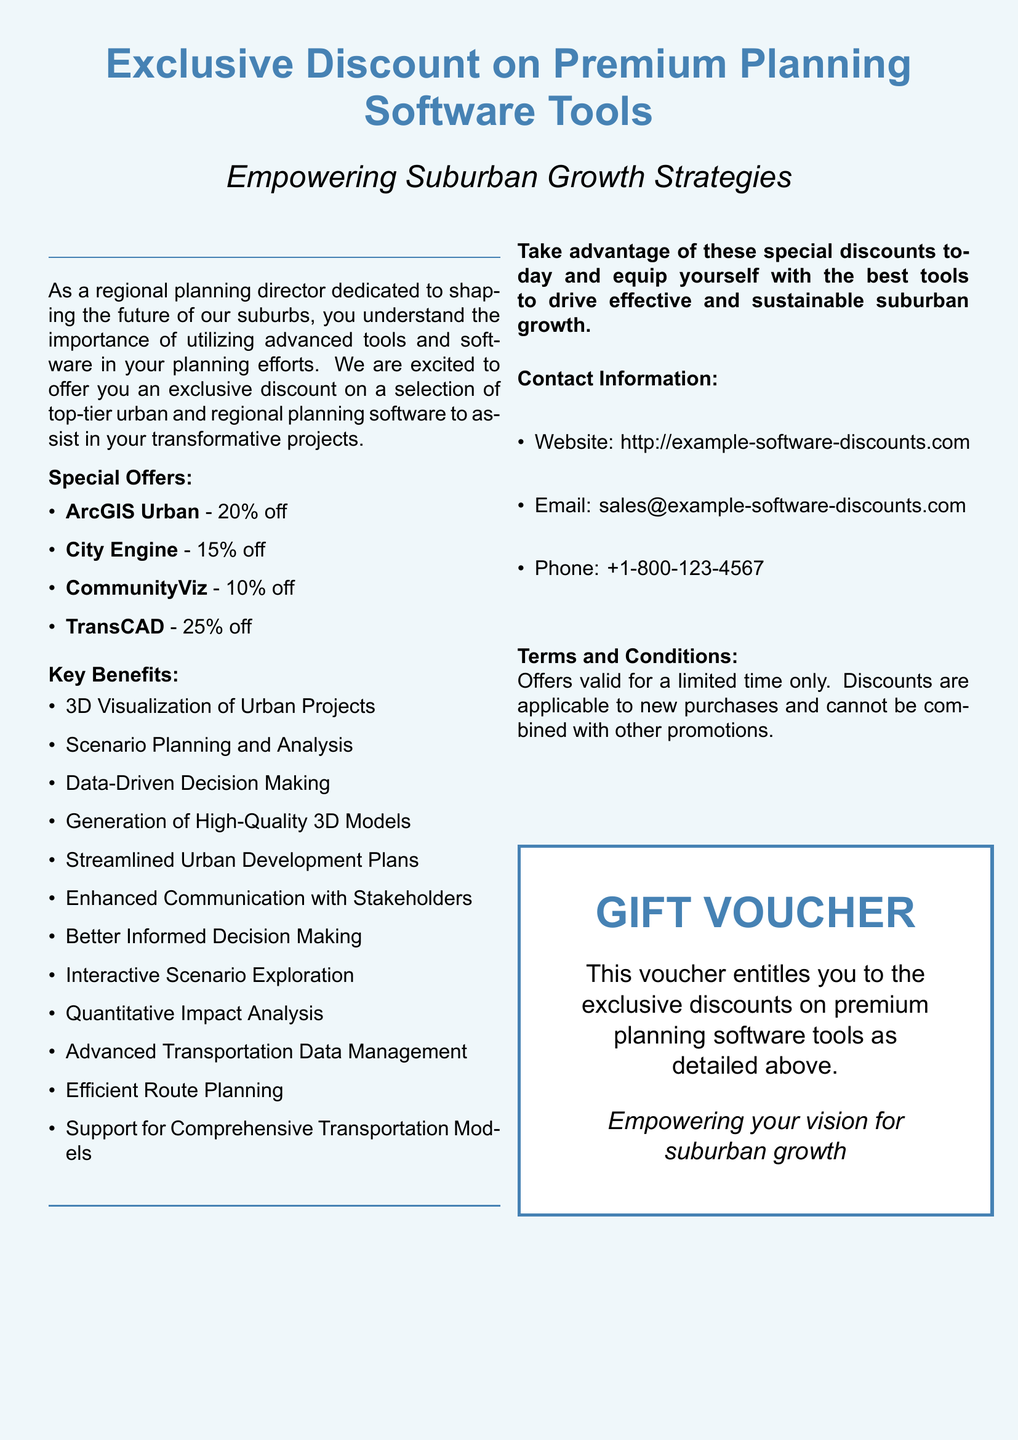What is the discount percentage for ArcGIS Urban? The discount for ArcGIS Urban is specifically mentioned in the document as 20%.
Answer: 20% What is the main purpose of the voucher? The main purpose of the voucher is detailed as empowering suburban growth strategies through the usage of advanced planning software tools.
Answer: Empowering suburban growth strategies How many software tools are listed with discounts? The document lists a total of four software tools that have specific discounts.
Answer: Four What is the maximum discount offered? The maximum discount can be calculated from the listed discounts, which is 25% for TransCAD.
Answer: 25% What type of benefits does the software offer? The document outlines key benefits such as 3D Visualization of Urban Projects and Scenario Planning and Analysis among others.
Answer: 3D Visualization of Urban Projects What is the validity period for the offers? The document states that the offers are valid for a limited time only, indicating a temporary period for these discounts.
Answer: Limited time only What is the contact phone number? The contact phone number is provided explicitly in the document as +1-800-123-4567.
Answer: +1-800-123-4567 What is the title of this document? The title of the document is prominently shown at the top as Exclusive Discount on Premium Planning Software Tools.
Answer: Exclusive Discount on Premium Planning Software Tools What does the gift voucher entitle the user to? The voucher entitles the user to exclusive discounts on premium planning software tools as detailed above.
Answer: Exclusive discounts on premium planning software tools 